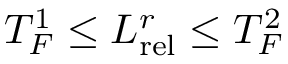Convert formula to latex. <formula><loc_0><loc_0><loc_500><loc_500>T _ { F } ^ { 1 } \leq L _ { r e l } ^ { r } \leq T _ { F } ^ { 2 }</formula> 